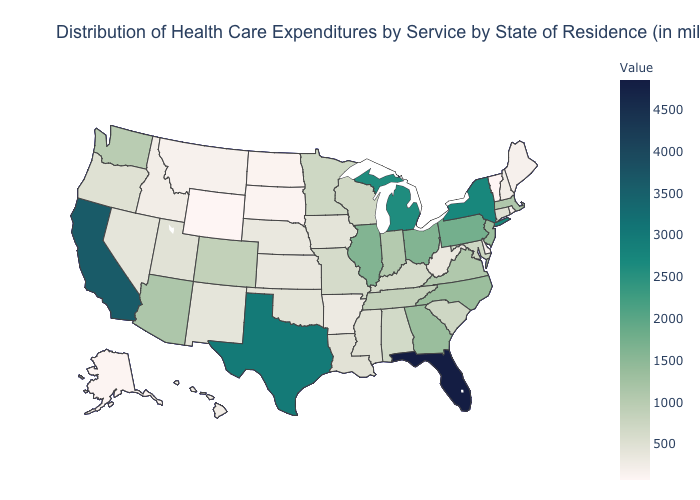Among the states that border Massachusetts , does New York have the highest value?
Keep it brief. Yes. Which states have the highest value in the USA?
Concise answer only. Florida. Is the legend a continuous bar?
Answer briefly. Yes. Among the states that border West Virginia , does Maryland have the lowest value?
Short answer required. No. Does Wyoming have a lower value than Arizona?
Short answer required. Yes. 